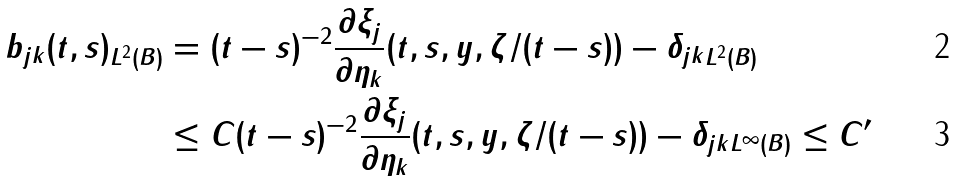Convert formula to latex. <formula><loc_0><loc_0><loc_500><loc_500>\| b _ { j k } ( t , s ) \| _ { L ^ { 2 } ( B ) } & = ( t - s ) ^ { - 2 } \| \frac { \partial \xi _ { j } } { \partial \eta _ { k } } ( t , s , y , \zeta / ( t - s ) ) - \delta _ { j k } \| _ { L ^ { 2 } ( B ) } \\ & \leq C ( t - s ) ^ { - 2 } \| \frac { \partial \xi _ { j } } { \partial \eta _ { k } } ( t , s , y , \zeta / ( t - s ) ) - \delta _ { j k } \| _ { L ^ { \infty } ( B ) } \leq C ^ { \prime }</formula> 